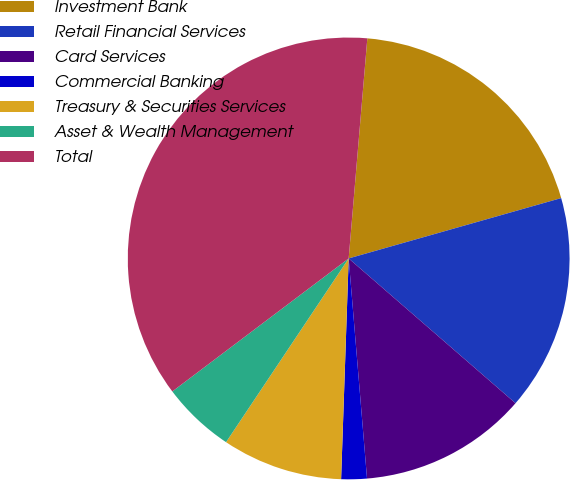Convert chart to OTSL. <chart><loc_0><loc_0><loc_500><loc_500><pie_chart><fcel>Investment Bank<fcel>Retail Financial Services<fcel>Card Services<fcel>Commercial Banking<fcel>Treasury & Securities Services<fcel>Asset & Wealth Management<fcel>Total<nl><fcel>19.25%<fcel>15.78%<fcel>12.3%<fcel>1.87%<fcel>8.82%<fcel>5.35%<fcel>36.63%<nl></chart> 